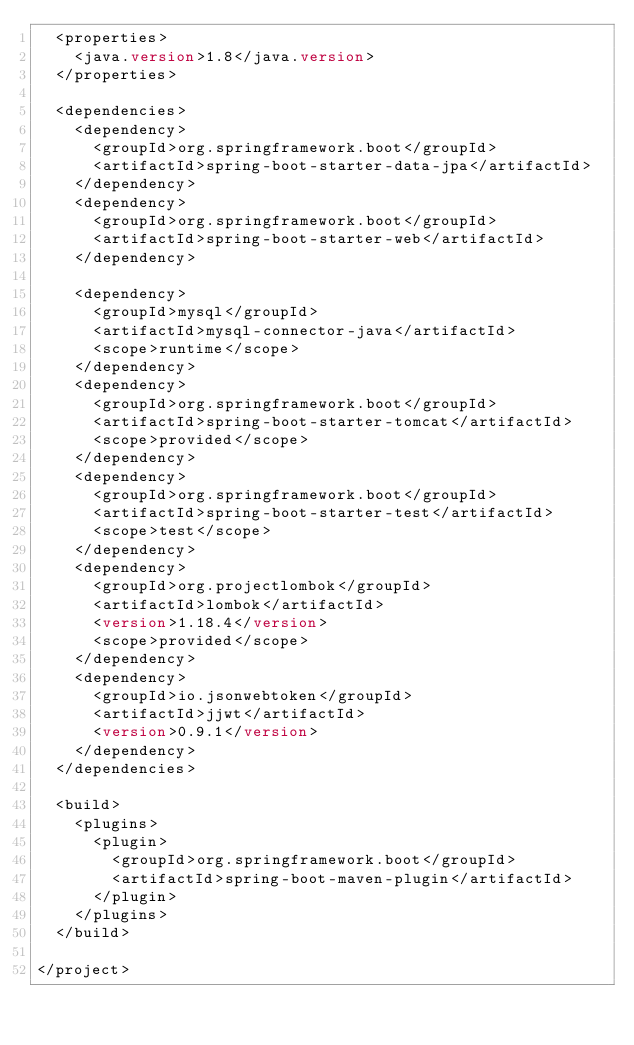<code> <loc_0><loc_0><loc_500><loc_500><_XML_>  <properties>
    <java.version>1.8</java.version>
  </properties>

  <dependencies>
    <dependency>
      <groupId>org.springframework.boot</groupId>
      <artifactId>spring-boot-starter-data-jpa</artifactId>
    </dependency>
    <dependency>
      <groupId>org.springframework.boot</groupId>
      <artifactId>spring-boot-starter-web</artifactId>
    </dependency>

    <dependency>
      <groupId>mysql</groupId>
      <artifactId>mysql-connector-java</artifactId>
      <scope>runtime</scope>
    </dependency>
    <dependency>
      <groupId>org.springframework.boot</groupId>
      <artifactId>spring-boot-starter-tomcat</artifactId>
      <scope>provided</scope>
    </dependency>
    <dependency>
      <groupId>org.springframework.boot</groupId>
      <artifactId>spring-boot-starter-test</artifactId>
      <scope>test</scope>
    </dependency>
    <dependency>
      <groupId>org.projectlombok</groupId>
      <artifactId>lombok</artifactId>
      <version>1.18.4</version>
      <scope>provided</scope>
    </dependency>
    <dependency>
      <groupId>io.jsonwebtoken</groupId>
      <artifactId>jjwt</artifactId>
      <version>0.9.1</version>
    </dependency>
  </dependencies>

  <build>
    <plugins>
      <plugin>
        <groupId>org.springframework.boot</groupId>
        <artifactId>spring-boot-maven-plugin</artifactId>
      </plugin>
    </plugins>
  </build>

</project>
</code> 